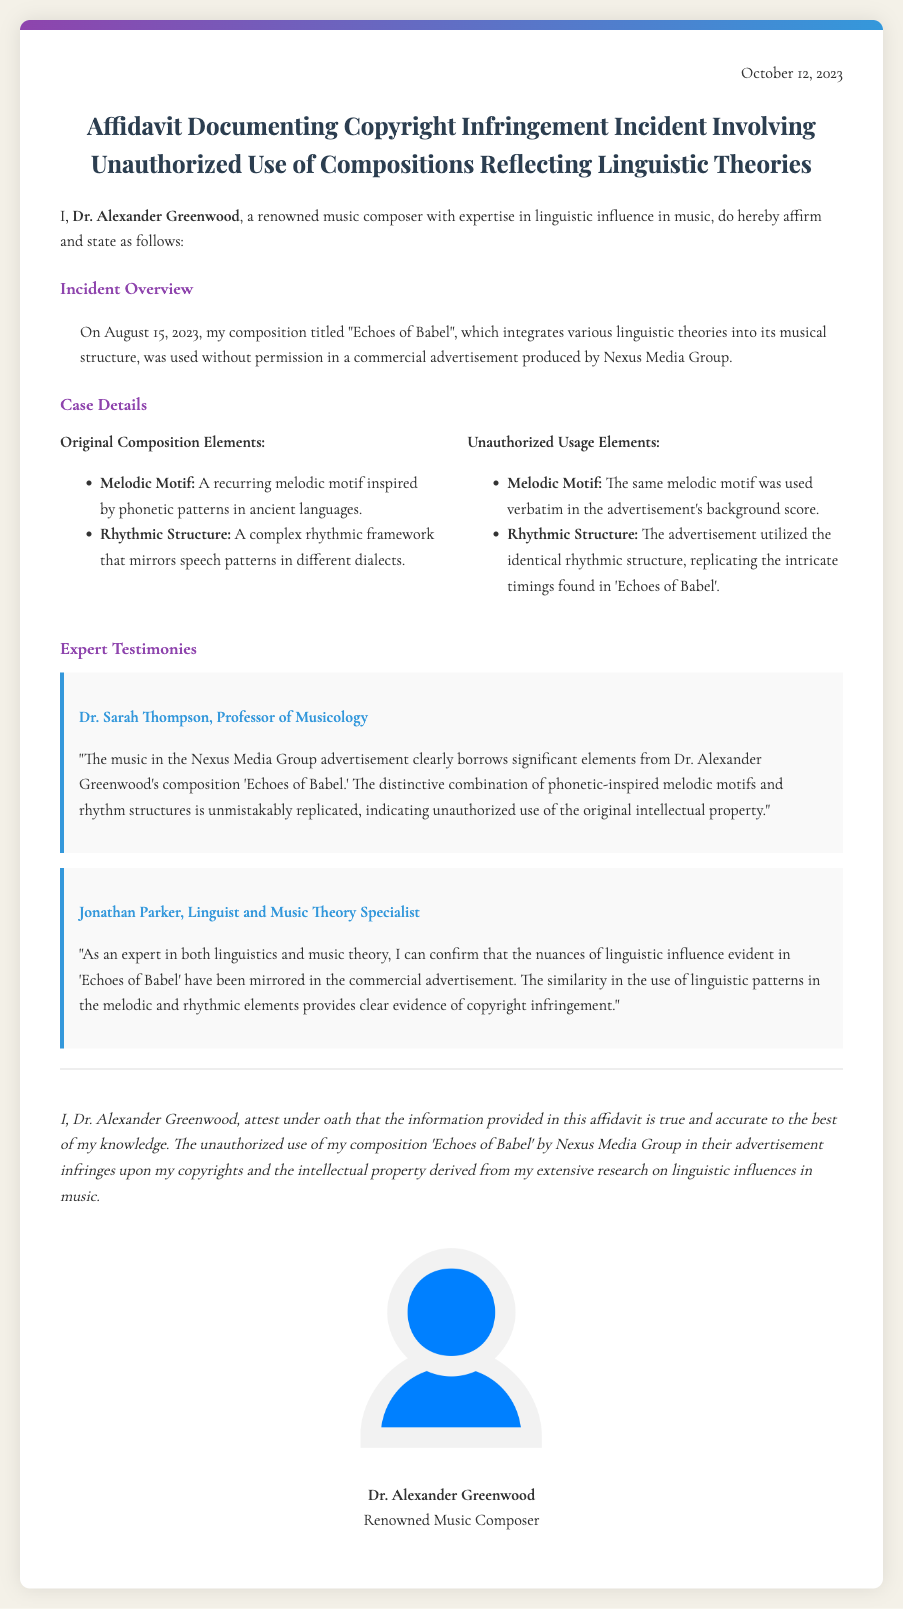What is the date of the affidavit? The date mentioned in the affidavit is found at the top of the document.
Answer: October 12, 2023 Who is the affiant? The affiant's name is stated at the beginning of the document.
Answer: Dr. Alexander Greenwood What is the title of the composition mentioned? The title of the composition is provided in the incident overview section.
Answer: Echoes of Babel Which company is accused of unauthorized use? The company alleged to have used the composition without permission is identified in the incident overview.
Answer: Nexus Media Group What are the two specific elements listed under "Original Composition Elements"? The document lists elements regarding the original composition which are categorized in the case details.
Answer: Melodic Motif, Rhythmic Structure What is the profession of Dr. Sarah Thompson? Dr. Sarah Thompson's profession is indicated in the expert testimonies section.
Answer: Professor of Musicology Which two experts provided testimonies? The document names the experts who attested to the copyright infringement.
Answer: Dr. Sarah Thompson, Jonathan Parker What does Dr. Greenwood attest to under oath? The affiant's affirmation is specified towards the end of the document.
Answer: The information provided is true and accurate 